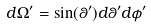Convert formula to latex. <formula><loc_0><loc_0><loc_500><loc_500>d \Omega ^ { \prime } = \sin ( \theta ^ { \prime } ) d \theta ^ { \prime } d \phi ^ { \prime }</formula> 